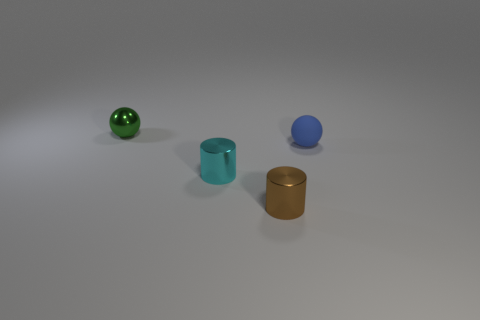Is the tiny sphere that is to the right of the green sphere made of the same material as the small thing behind the tiny matte ball?
Your response must be concise. No. There is a cyan object that is the same material as the tiny brown cylinder; what is its shape?
Ensure brevity in your answer.  Cylinder. Are there any other things that have the same color as the shiny ball?
Provide a short and direct response. No. How many large red metallic cubes are there?
Your answer should be compact. 0. The object that is both behind the tiny cyan thing and to the left of the small blue sphere has what shape?
Provide a short and direct response. Sphere. There is a tiny metallic object that is behind the cyan cylinder that is on the left side of the ball that is in front of the tiny green sphere; what shape is it?
Make the answer very short. Sphere. There is a thing that is both behind the cyan object and on the right side of the cyan shiny object; what is it made of?
Ensure brevity in your answer.  Rubber. How many other green spheres have the same size as the green metallic sphere?
Your answer should be compact. 0. How many metal objects are large green cubes or tiny green spheres?
Offer a terse response. 1. What is the blue sphere made of?
Provide a succinct answer. Rubber. 